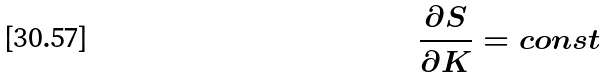<formula> <loc_0><loc_0><loc_500><loc_500>\frac { \partial S } { \partial K } = c o n s t</formula> 